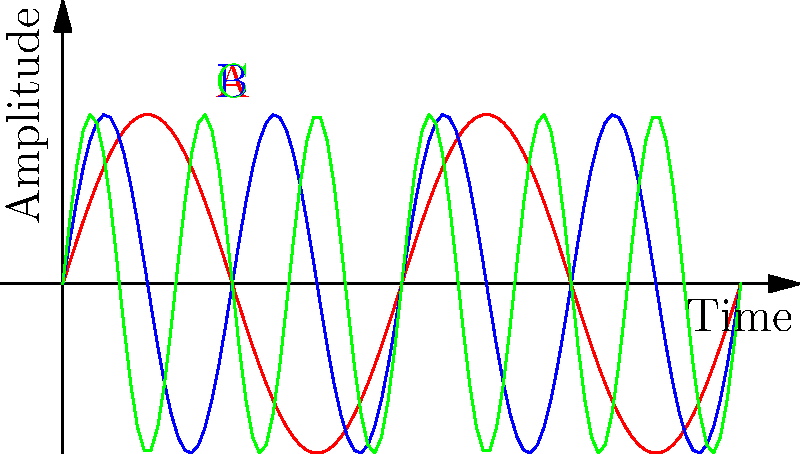As a DJ, you're familiar with visualizing sound waves. The graph shows three different sound waves (A, B, and C) over the same time period. Which wave has the highest frequency? To determine the frequency of sound waves, we need to analyze the number of complete cycles within a given time period. Here's how to approach this:

1. Observe that all three waves start and end at the same points on the time axis, indicating they cover the same time period.

2. Count the number of complete cycles for each wave:
   - Wave A (red): Completes 1 full cycle
   - Wave B (blue): Completes 2 full cycles
   - Wave C (green): Completes 3 full cycles

3. Recall that frequency is defined as the number of cycles per unit time. Since all waves cover the same time period, the wave with the most cycles has the highest frequency.

4. Therefore, Wave C, with 3 complete cycles, has the highest frequency among the three waves shown.

In audio terms, Wave C would correspond to the highest pitch among these three sounds.
Answer: C 